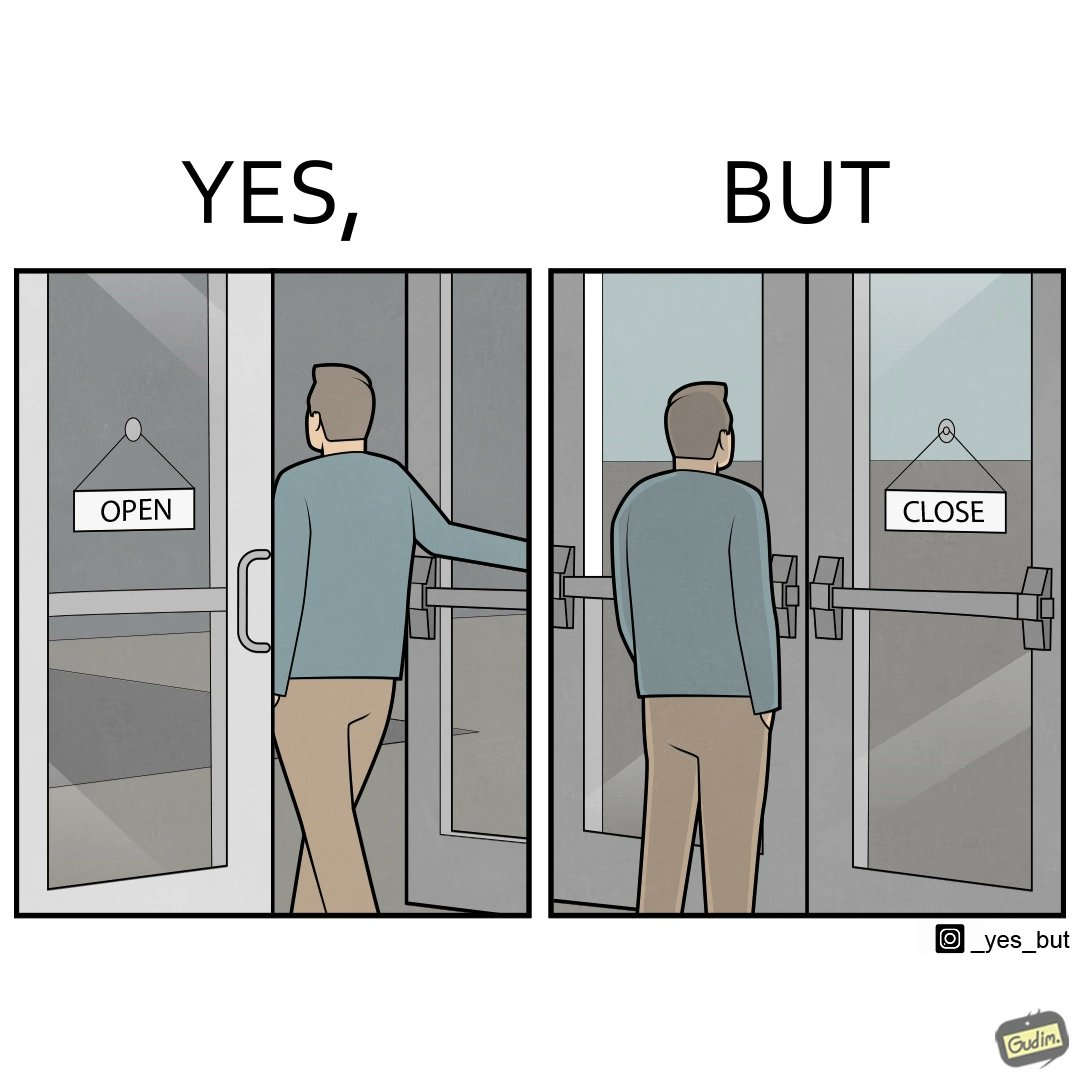Explain why this image is satirical. The image is funny because a person opens a door with the sign 'OPEN', meaning the place is open. However, once the person enters the building and looks back, the other side of the sign reads 'CLOSE', which ideally should not be the case, as the place is actually open. 